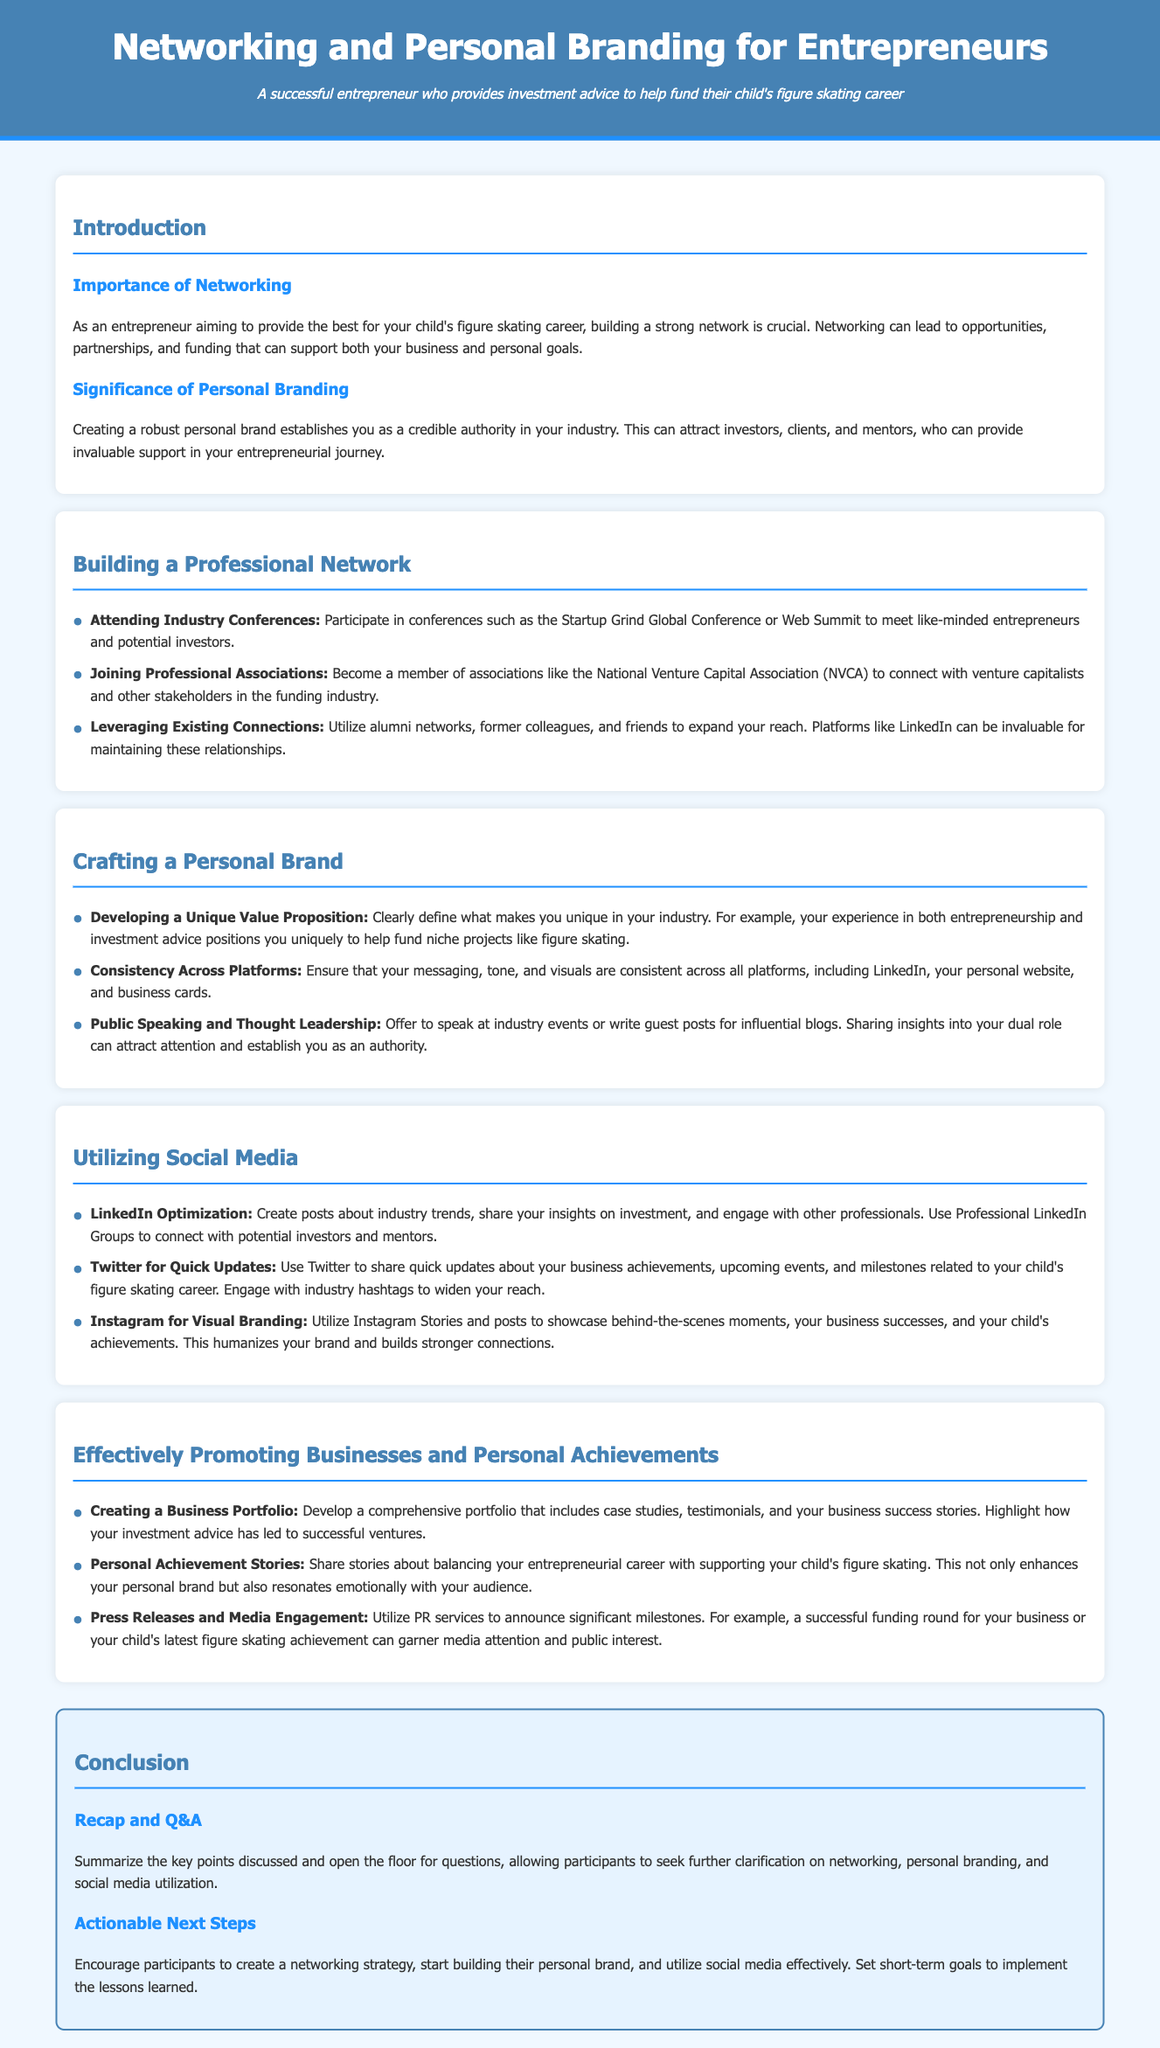What is the title of the lesson plan? The title of the lesson plan is stated at the beginning of the document.
Answer: Networking and Personal Branding for Entrepreneurs What is one event mentioned for networking opportunities? The document lists specific conferences that are recommended for networking.
Answer: Startup Grind Global Conference Which professional association is suggested for networking? The document names a professional association that can help in connecting with venture capitalists.
Answer: National Venture Capital Association What is one way to utilize LinkedIn according to the lesson plan? The lesson plan describes how to engage with LinkedIn to connect with professionals.
Answer: Create posts about industry trends What should be consistent across platforms in personal branding? The lesson emphasizes the need for consistency in certain elements for personal branding.
Answer: Messaging, tone, and visuals How many steps are mentioned for effectively promoting personal achievements? The document provides a specific number of strategies for promoting businesses and personal achievements.
Answer: Three What is the purpose of creating a business portfolio? The lesson plan outlines a key reason for having a business portfolio.
Answer: To include case studies, testimonials, and success stories What social media platform is recommended for visual branding? The lesson specifies a particular social media platform that can enhance visual branding efforts.
Answer: Instagram What is one actionable next step participants are encouraged to take? The conclusion provides suggestions for steps participants should implement after the lesson.
Answer: Create a networking strategy 